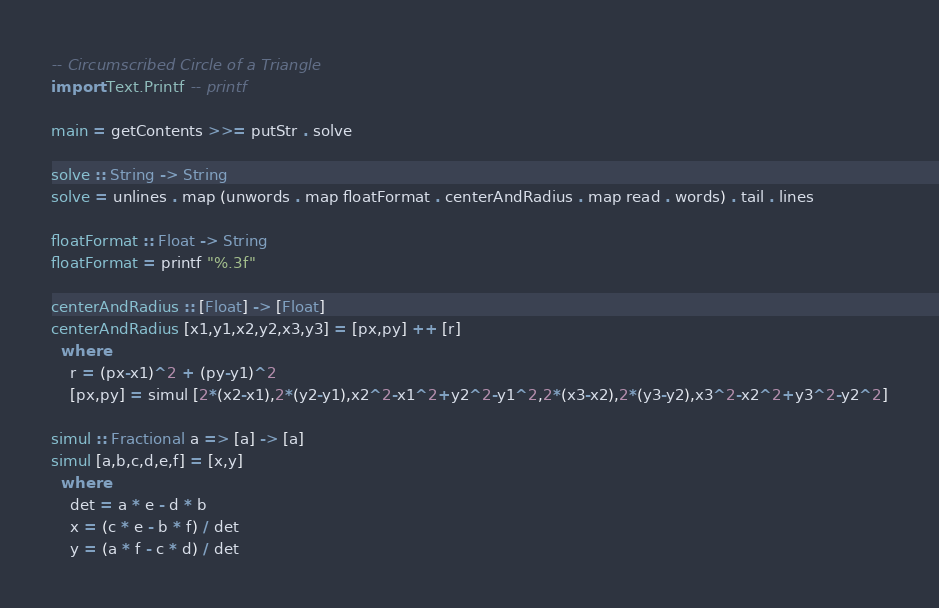Convert code to text. <code><loc_0><loc_0><loc_500><loc_500><_Haskell_>-- Circumscribed Circle of a Triangle
import Text.Printf -- printf

main = getContents >>= putStr . solve

solve :: String -> String
solve = unlines . map (unwords . map floatFormat . centerAndRadius . map read . words) . tail . lines

floatFormat :: Float -> String
floatFormat = printf "%.3f"

centerAndRadius :: [Float] -> [Float]
centerAndRadius [x1,y1,x2,y2,x3,y3] = [px,py] ++ [r]
  where
    r = (px-x1)^2 + (py-y1)^2
    [px,py] = simul [2*(x2-x1),2*(y2-y1),x2^2-x1^2+y2^2-y1^2,2*(x3-x2),2*(y3-y2),x3^2-x2^2+y3^2-y2^2]

simul :: Fractional a => [a] -> [a]
simul [a,b,c,d,e,f] = [x,y]
  where
    det = a * e - d * b
    x = (c * e - b * f) / det
    y = (a * f - c * d) / det</code> 